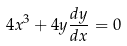Convert formula to latex. <formula><loc_0><loc_0><loc_500><loc_500>4 x ^ { 3 } + 4 y \frac { d y } { d x } = 0</formula> 